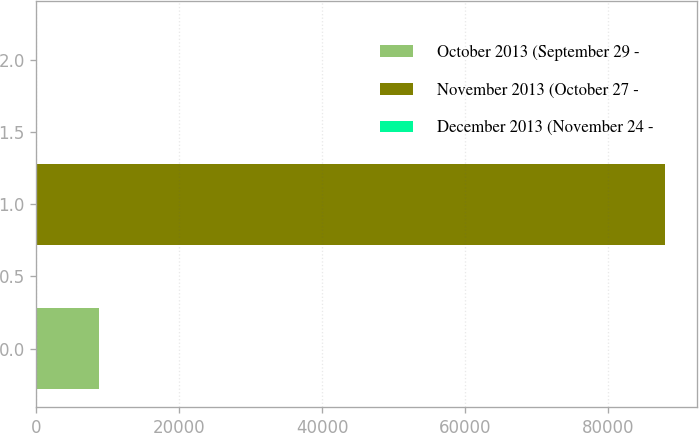Convert chart. <chart><loc_0><loc_0><loc_500><loc_500><bar_chart><fcel>October 2013 (September 29 -<fcel>November 2013 (October 27 -<fcel>December 2013 (November 24 -<nl><fcel>8800.32<fcel>88000<fcel>0.36<nl></chart> 